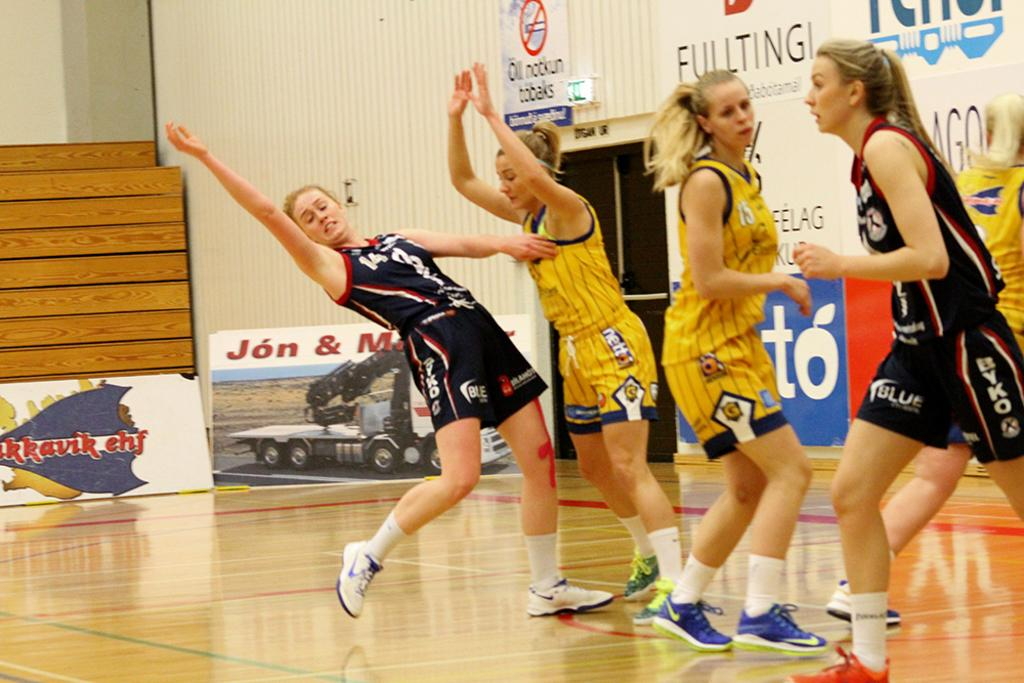What is the surface that the women are standing on in the image? The women are standing on a wooden court in the image. How are the women positioned in relation to each other? The women are in different positions in the image. What is located in the background of the image? There is a metal wall with a door in the background of the image. What is attached to the metal wall? There are banners on the metal wall. What type of steel is used to make the stew in the image? There is no stew present in the image, and therefore no steel is used to make it. 